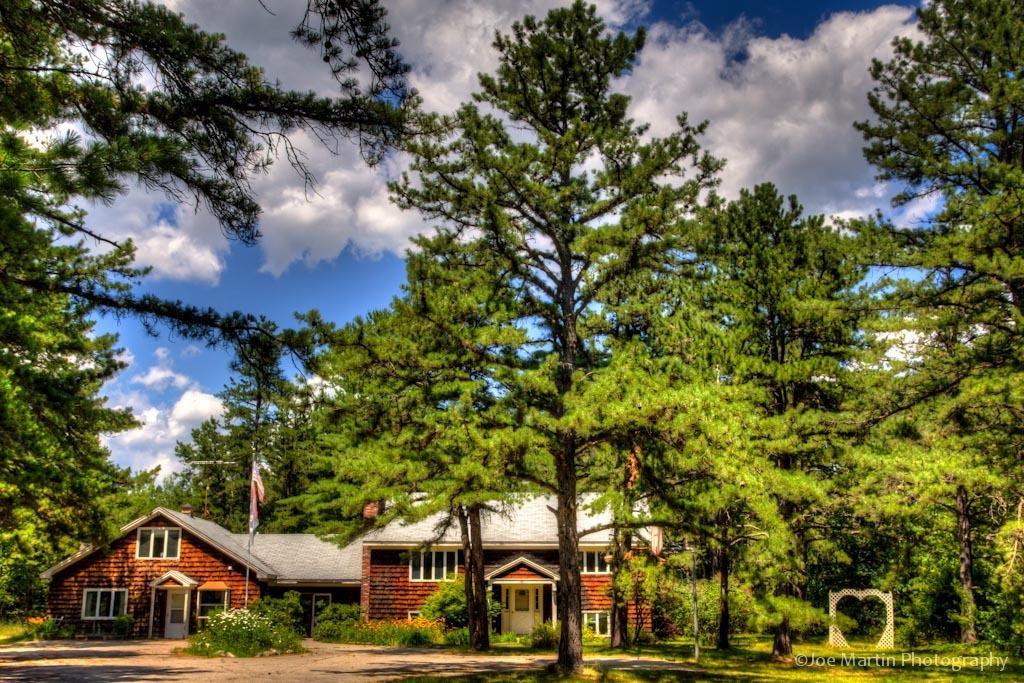In one or two sentences, can you explain what this image depicts? In the image there are houses with roofs, walls, windows, poles and pillars. In front of the houses there are plants with flowers. And in the image there are many trees. At the top of the image in the background there is sky with clouds. In the bottom right corner of the image there is a watermark.  